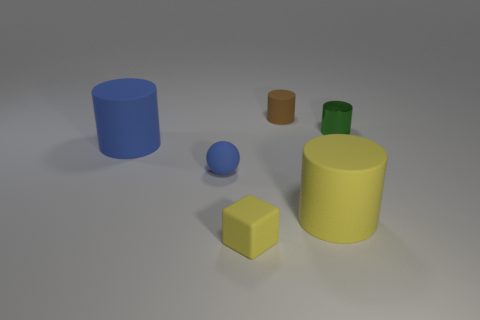Subtract all brown matte cylinders. How many cylinders are left? 3 Subtract all blue cylinders. How many cylinders are left? 3 Add 3 large brown metallic objects. How many objects exist? 9 Subtract all gray cylinders. Subtract all purple blocks. How many cylinders are left? 4 Subtract all blocks. How many objects are left? 5 Subtract all blue rubber balls. Subtract all tiny cylinders. How many objects are left? 3 Add 6 shiny things. How many shiny things are left? 7 Add 5 cubes. How many cubes exist? 6 Subtract 0 purple cylinders. How many objects are left? 6 